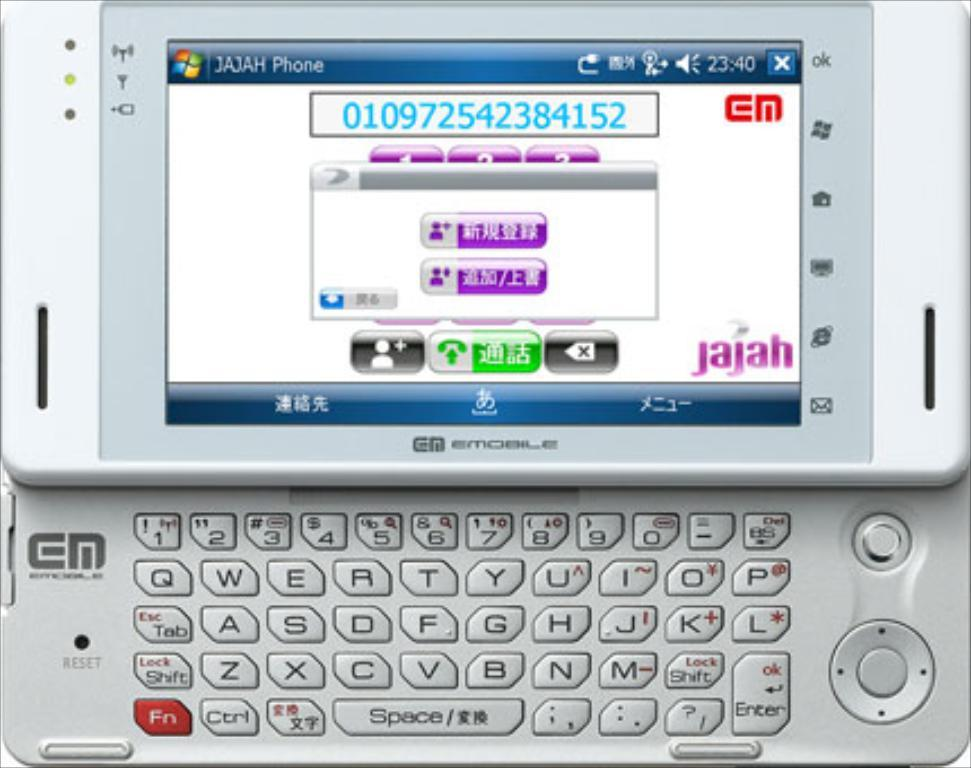<image>
Describe the image concisely. A flip out phone is displaying Chinese text on the screen with the jajah logo on the lower right side of the screen. 